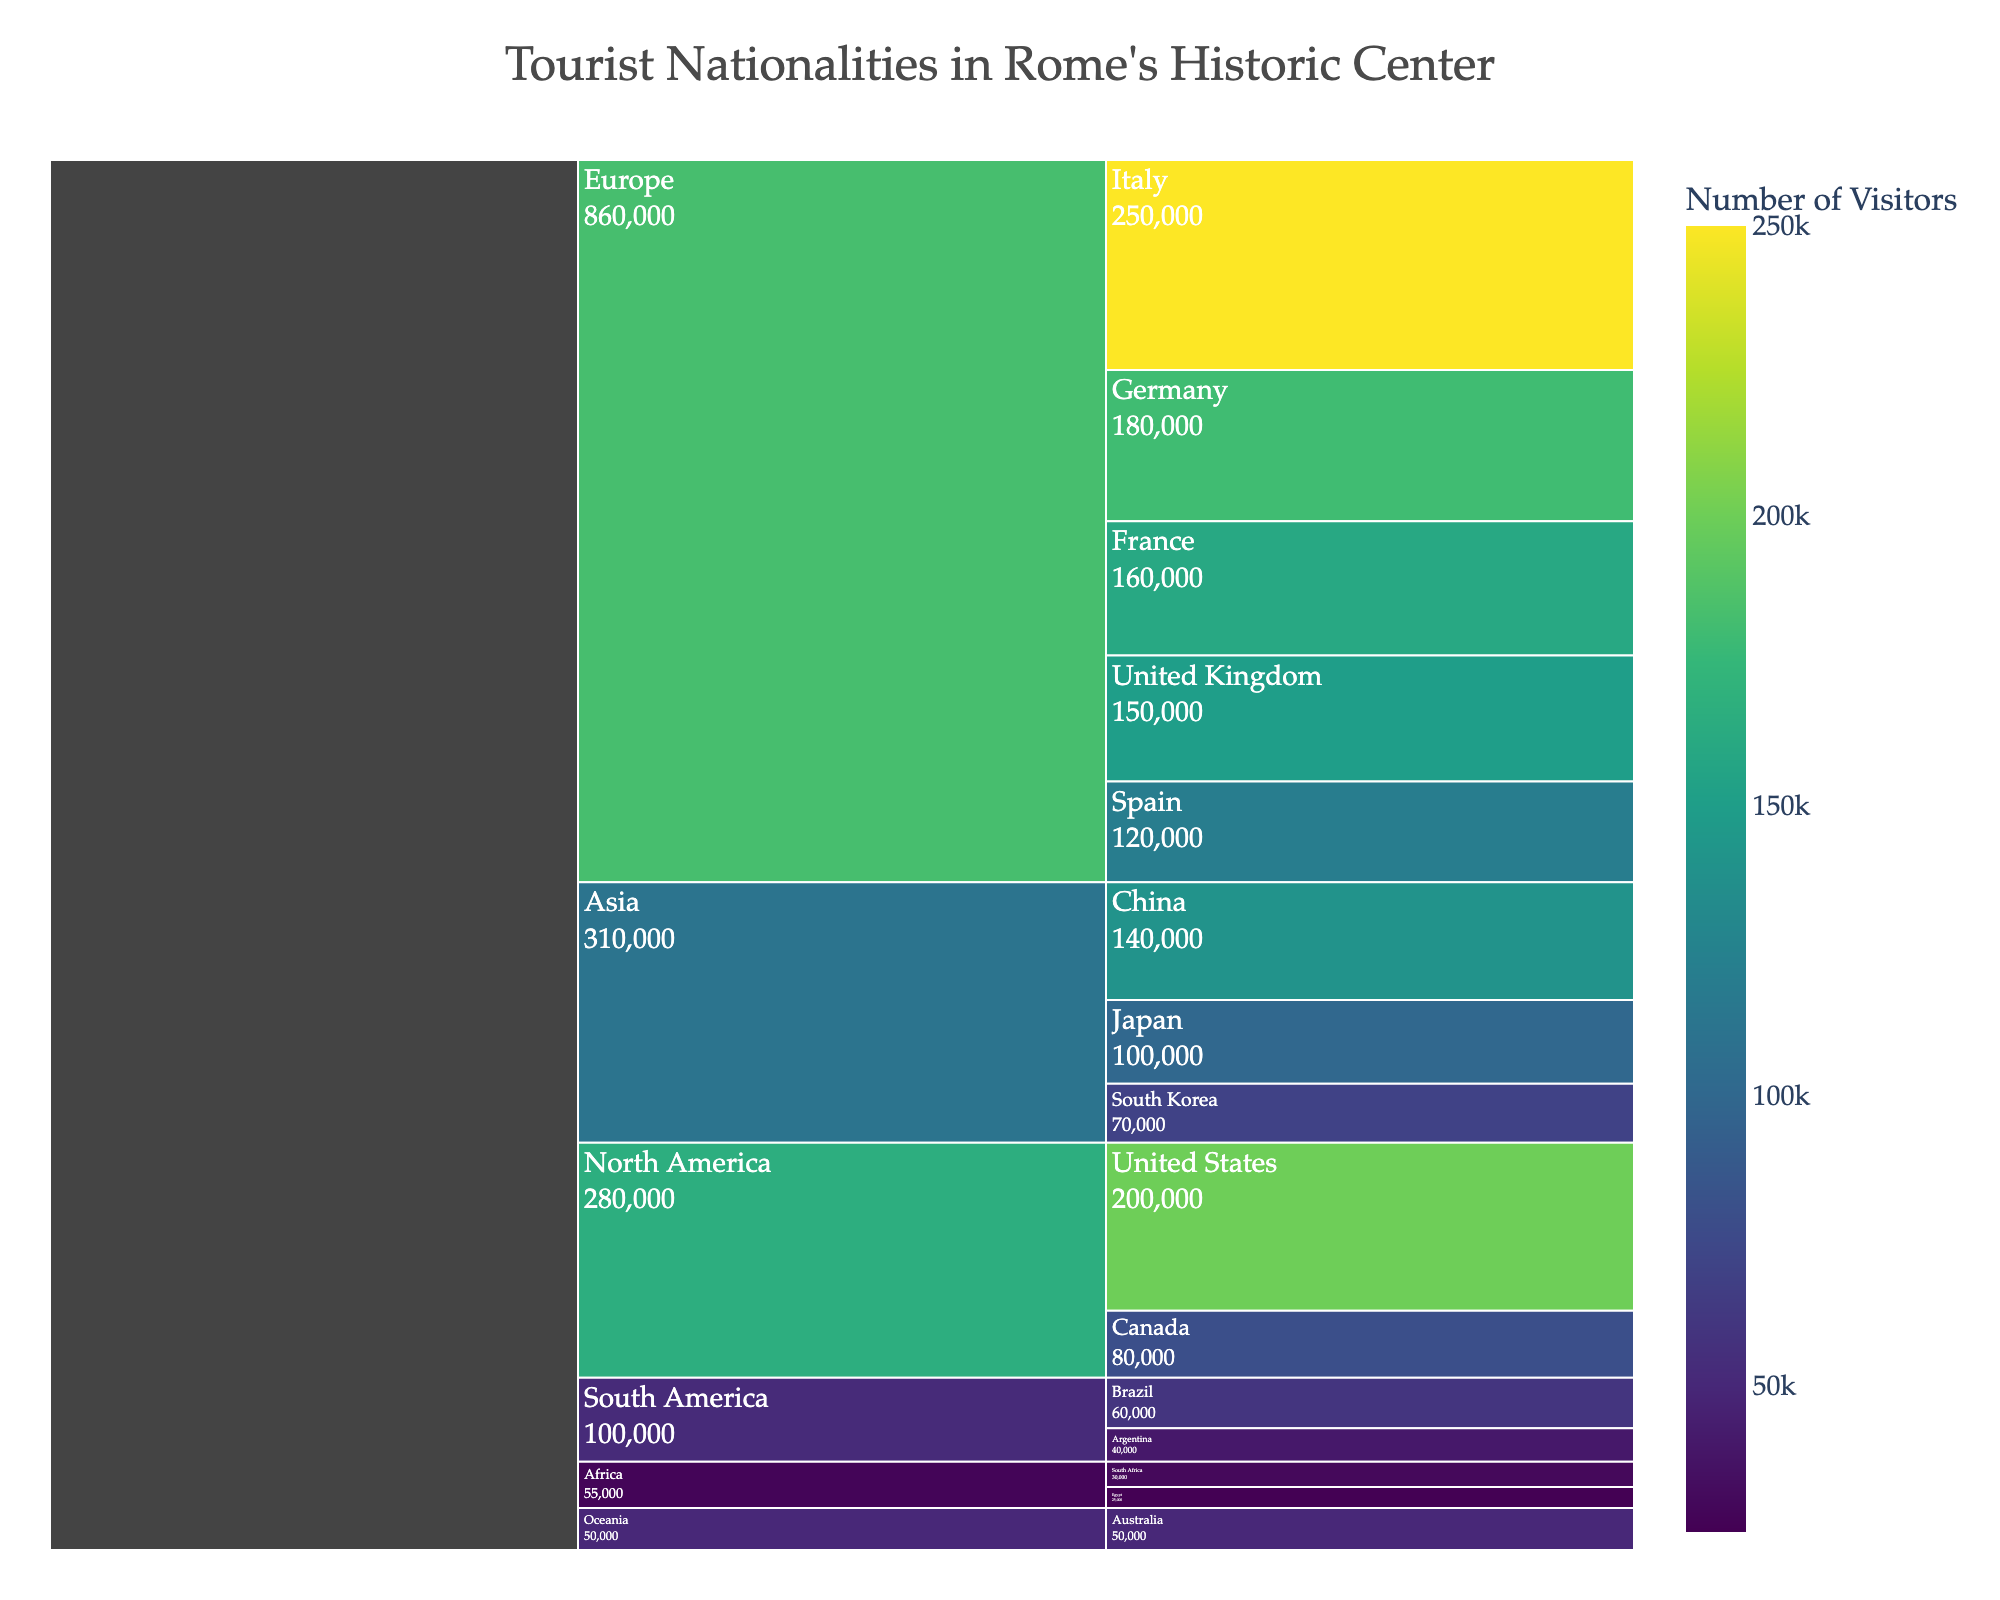what does the title of the icicle chart represent? The title reads 'Tourist Nationalities in Rome's Historic Center', which signifies that the chart breaks down the number of visitors from different nationalities coming to Rome's historic center.
Answer: Tourist Nationalities in Rome's Historic Center How many visitors come from Canada? The chart shows a label for Canada, with the number of visitors listed.
Answer: 80,000 Which continent has the highest number of total visitors? To determine the continent with the highest number of visitors, sum up the visitors for each continent and compare. Europe has the highest with a sum of (250,000 + 180,000 + 160,000 + 150,000 + 120,000) = 860,000 visitors.
Answer: Europe What is the sum of visitors from South America and Oceania? South America: 60,000 (Brazil) + 40,000 (Argentina) = 100,000; Oceania: 50,000 (Australia) = 50,000; Total = 100,000 + 50,000 = 150,000 visitors.
Answer: 150,000 Which country in Asia brings in the most visitors? Compare the visitor numbers for China, Japan, and South Korea. China has the most with 140,000 visitors.
Answer: China Are there more visitors from the United States or Japan? The visitors from the United States (200,000) are more compared to those from Japan (100,000).
Answer: United States What is the average number of visitors from the African countries listed? Sum the visitors (South Africa: 30,000, Egypt: 25,000) = 55,000; Average = 55,000 / 2 = 27,500.
Answer: 27,500 Which country in Europe has the fewest visitors? Among Italy, Germany, France, the United Kingdom, and Spain, Spain has the fewest with 120,000 visitors.
Answer: Spain Does South Korea contribute more visitors to Rome's historic center than Australia? Compare the visitors from South Korea (70,000) and Australia (50,000); South Korea contributes more.
Answer: South Korea What is the total number of visitors from North America? Sum the visitors from the United States (200,000) and Canada (80,000) = 280,000 visitors.
Answer: 280,000 